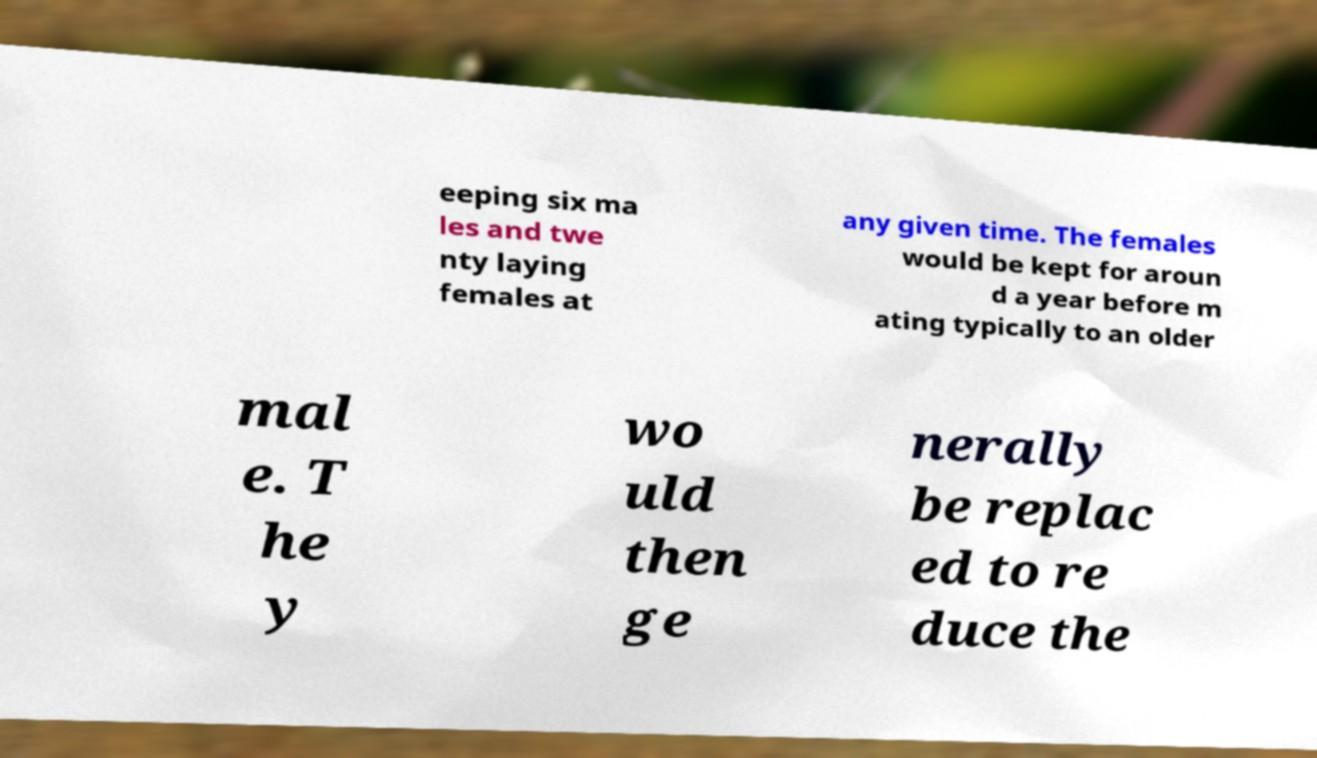I need the written content from this picture converted into text. Can you do that? eeping six ma les and twe nty laying females at any given time. The females would be kept for aroun d a year before m ating typically to an older mal e. T he y wo uld then ge nerally be replac ed to re duce the 